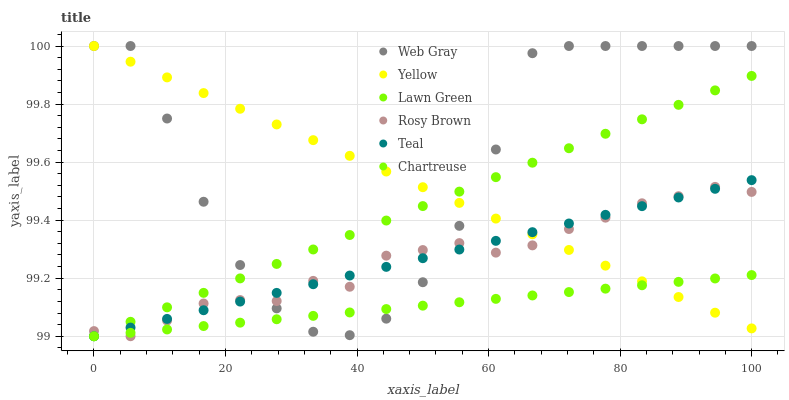Does Chartreuse have the minimum area under the curve?
Answer yes or no. Yes. Does Web Gray have the maximum area under the curve?
Answer yes or no. Yes. Does Rosy Brown have the minimum area under the curve?
Answer yes or no. No. Does Rosy Brown have the maximum area under the curve?
Answer yes or no. No. Is Lawn Green the smoothest?
Answer yes or no. Yes. Is Web Gray the roughest?
Answer yes or no. Yes. Is Rosy Brown the smoothest?
Answer yes or no. No. Is Rosy Brown the roughest?
Answer yes or no. No. Does Lawn Green have the lowest value?
Answer yes or no. Yes. Does Web Gray have the lowest value?
Answer yes or no. No. Does Yellow have the highest value?
Answer yes or no. Yes. Does Rosy Brown have the highest value?
Answer yes or no. No. Does Chartreuse intersect Lawn Green?
Answer yes or no. Yes. Is Chartreuse less than Lawn Green?
Answer yes or no. No. Is Chartreuse greater than Lawn Green?
Answer yes or no. No. 